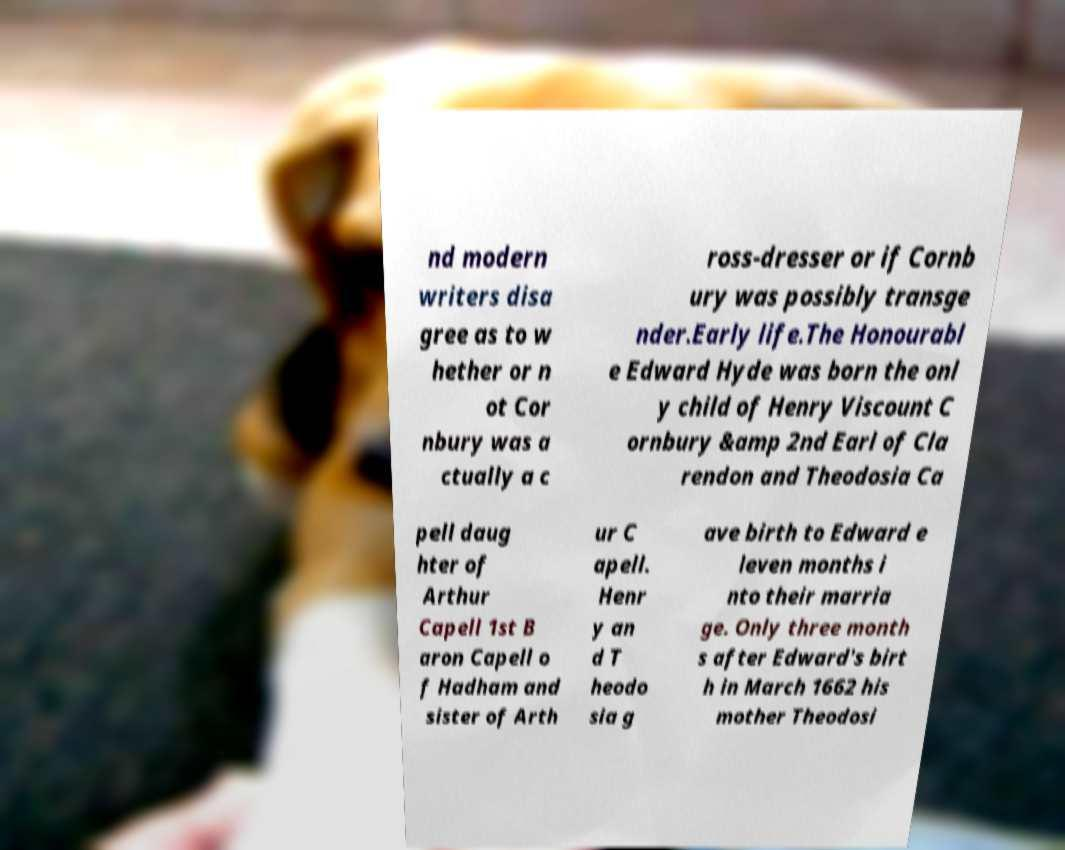Could you assist in decoding the text presented in this image and type it out clearly? nd modern writers disa gree as to w hether or n ot Cor nbury was a ctually a c ross-dresser or if Cornb ury was possibly transge nder.Early life.The Honourabl e Edward Hyde was born the onl y child of Henry Viscount C ornbury &amp 2nd Earl of Cla rendon and Theodosia Ca pell daug hter of Arthur Capell 1st B aron Capell o f Hadham and sister of Arth ur C apell. Henr y an d T heodo sia g ave birth to Edward e leven months i nto their marria ge. Only three month s after Edward's birt h in March 1662 his mother Theodosi 